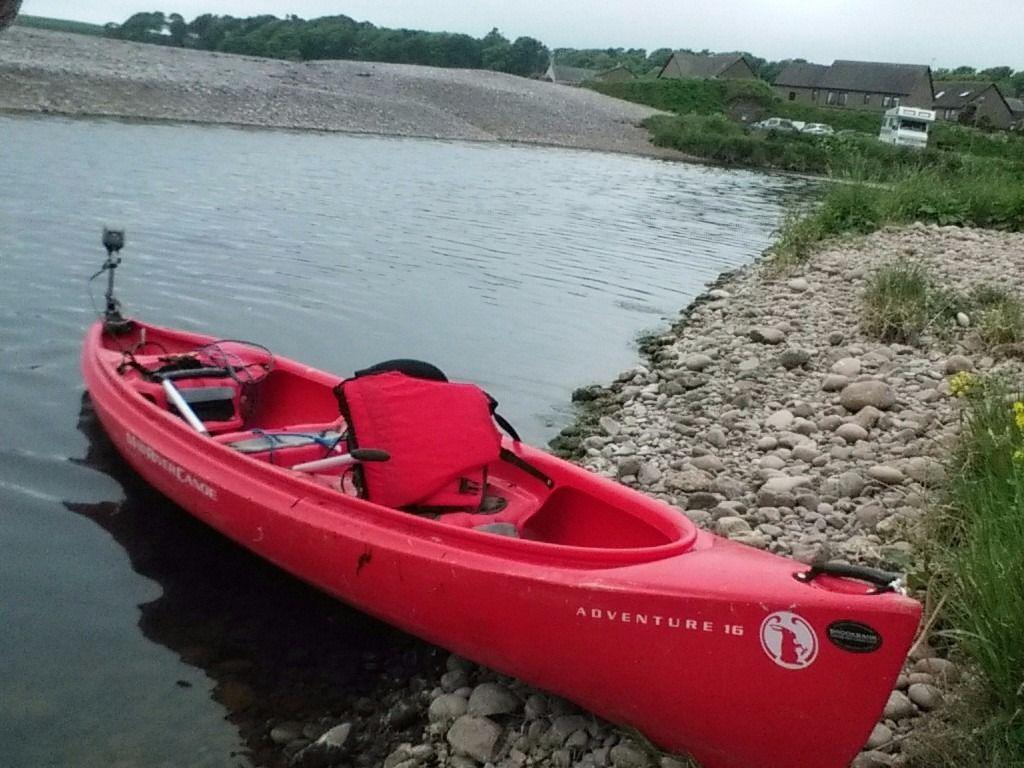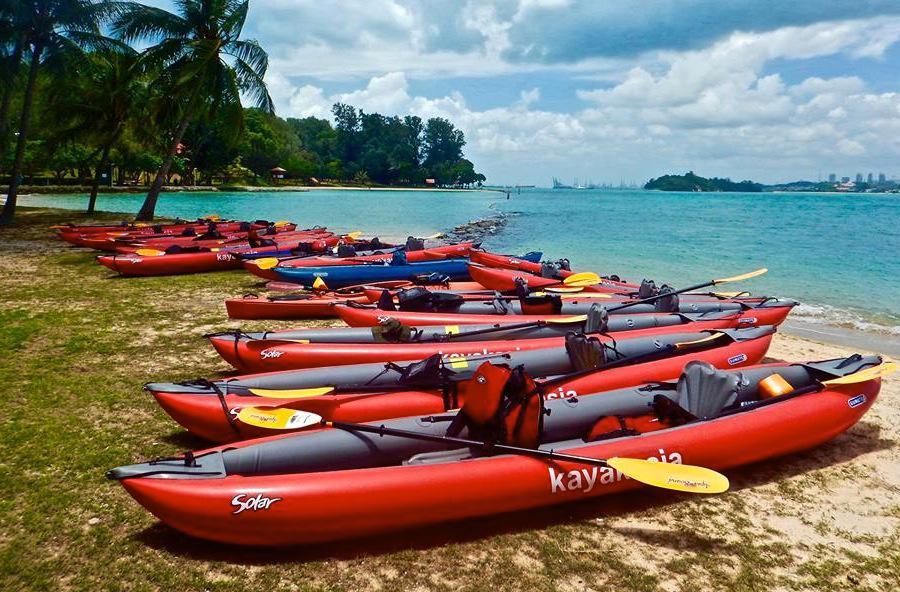The first image is the image on the left, the second image is the image on the right. Examine the images to the left and right. Is the description "One of the images contain only one boat." accurate? Answer yes or no. Yes. The first image is the image on the left, the second image is the image on the right. Evaluate the accuracy of this statement regarding the images: "An image shows a curving row of at least ten canoes, none containing humans.". Is it true? Answer yes or no. Yes. 